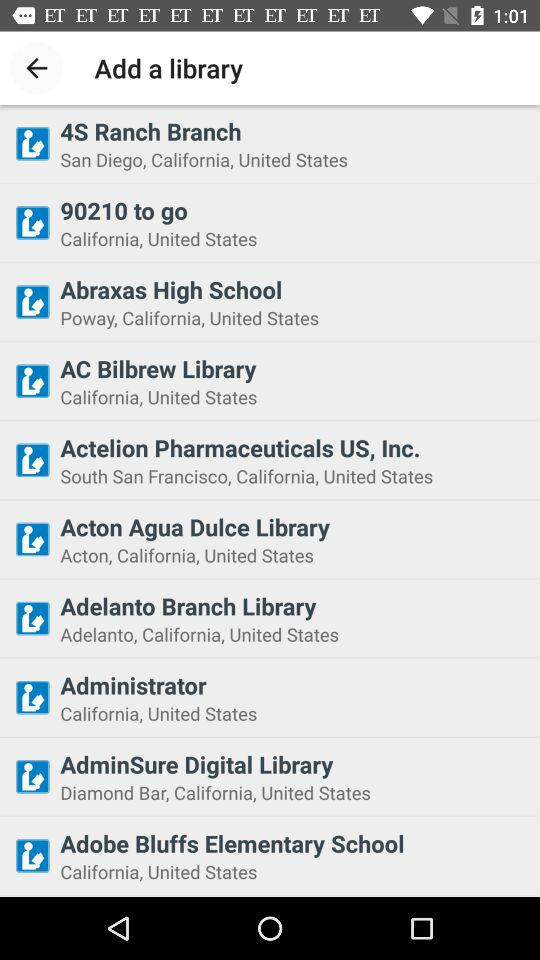How many libraries are yet to be added?
When the provided information is insufficient, respond with <no answer>. <no answer> 